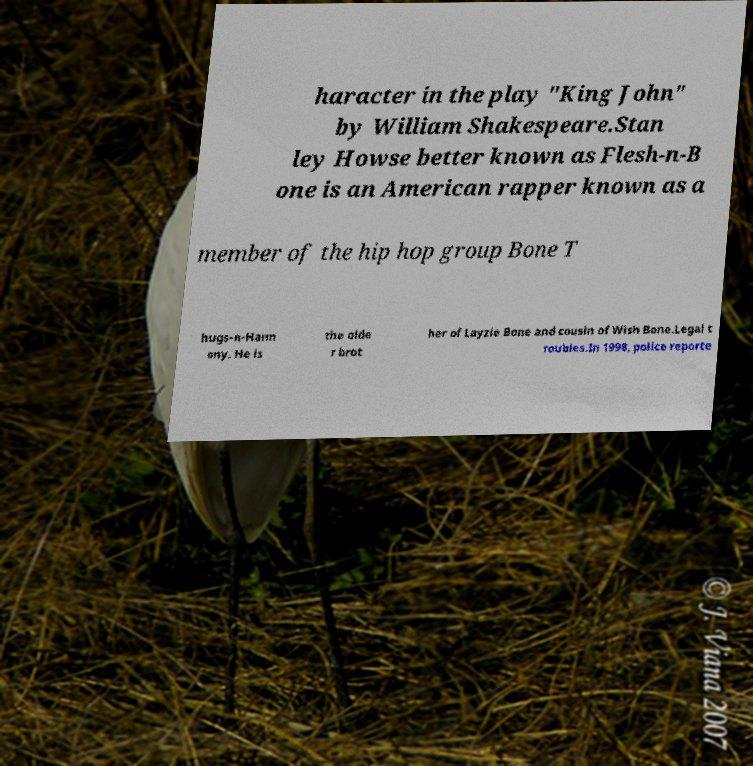There's text embedded in this image that I need extracted. Can you transcribe it verbatim? haracter in the play "King John" by William Shakespeare.Stan ley Howse better known as Flesh-n-B one is an American rapper known as a member of the hip hop group Bone T hugs-n-Harm ony. He is the olde r brot her of Layzie Bone and cousin of Wish Bone.Legal t roubles.In 1998, police reporte 